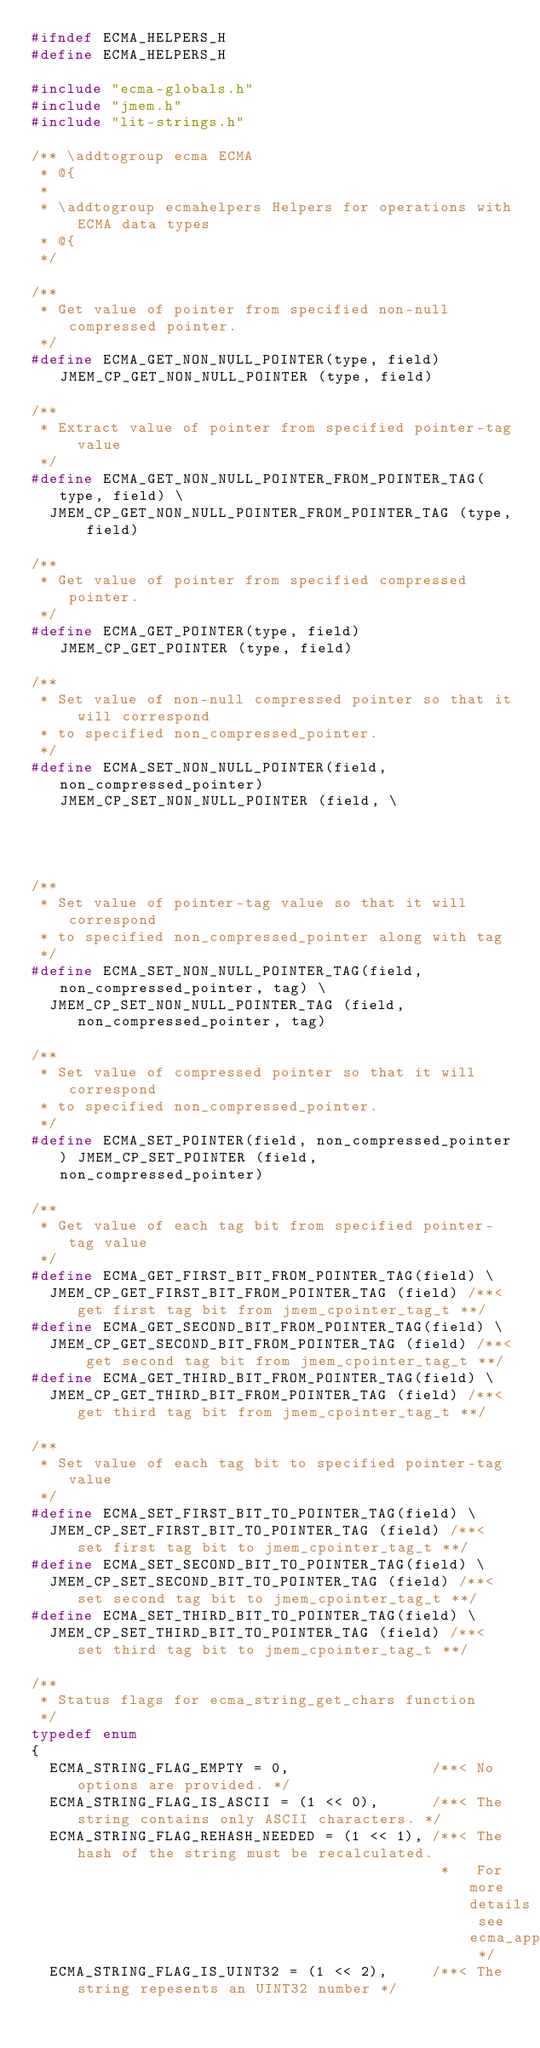Convert code to text. <code><loc_0><loc_0><loc_500><loc_500><_C_>#ifndef ECMA_HELPERS_H
#define ECMA_HELPERS_H

#include "ecma-globals.h"
#include "jmem.h"
#include "lit-strings.h"

/** \addtogroup ecma ECMA
 * @{
 *
 * \addtogroup ecmahelpers Helpers for operations with ECMA data types
 * @{
 */

/**
 * Get value of pointer from specified non-null compressed pointer.
 */
#define ECMA_GET_NON_NULL_POINTER(type, field) JMEM_CP_GET_NON_NULL_POINTER (type, field)

/**
 * Extract value of pointer from specified pointer-tag value
 */
#define ECMA_GET_NON_NULL_POINTER_FROM_POINTER_TAG(type, field) \
  JMEM_CP_GET_NON_NULL_POINTER_FROM_POINTER_TAG (type, field)

/**
 * Get value of pointer from specified compressed pointer.
 */
#define ECMA_GET_POINTER(type, field) JMEM_CP_GET_POINTER (type, field)

/**
 * Set value of non-null compressed pointer so that it will correspond
 * to specified non_compressed_pointer.
 */
#define ECMA_SET_NON_NULL_POINTER(field, non_compressed_pointer) JMEM_CP_SET_NON_NULL_POINTER (field, \
                                                                                               non_compressed_pointer)

/**
 * Set value of pointer-tag value so that it will correspond
 * to specified non_compressed_pointer along with tag
 */
#define ECMA_SET_NON_NULL_POINTER_TAG(field, non_compressed_pointer, tag) \
  JMEM_CP_SET_NON_NULL_POINTER_TAG (field, non_compressed_pointer, tag)

/**
 * Set value of compressed pointer so that it will correspond
 * to specified non_compressed_pointer.
 */
#define ECMA_SET_POINTER(field, non_compressed_pointer) JMEM_CP_SET_POINTER (field, non_compressed_pointer)

/**
 * Get value of each tag bit from specified pointer-tag value
 */
#define ECMA_GET_FIRST_BIT_FROM_POINTER_TAG(field) \
  JMEM_CP_GET_FIRST_BIT_FROM_POINTER_TAG (field) /**< get first tag bit from jmem_cpointer_tag_t **/
#define ECMA_GET_SECOND_BIT_FROM_POINTER_TAG(field) \
  JMEM_CP_GET_SECOND_BIT_FROM_POINTER_TAG (field) /**< get second tag bit from jmem_cpointer_tag_t **/
#define ECMA_GET_THIRD_BIT_FROM_POINTER_TAG(field) \
  JMEM_CP_GET_THIRD_BIT_FROM_POINTER_TAG (field) /**< get third tag bit from jmem_cpointer_tag_t **/

/**
 * Set value of each tag bit to specified pointer-tag value
 */
#define ECMA_SET_FIRST_BIT_TO_POINTER_TAG(field) \
  JMEM_CP_SET_FIRST_BIT_TO_POINTER_TAG (field) /**< set first tag bit to jmem_cpointer_tag_t **/
#define ECMA_SET_SECOND_BIT_TO_POINTER_TAG(field) \
  JMEM_CP_SET_SECOND_BIT_TO_POINTER_TAG (field) /**< set second tag bit to jmem_cpointer_tag_t **/
#define ECMA_SET_THIRD_BIT_TO_POINTER_TAG(field) \
  JMEM_CP_SET_THIRD_BIT_TO_POINTER_TAG (field) /**< set third tag bit to jmem_cpointer_tag_t **/

/**
 * Status flags for ecma_string_get_chars function
 */
typedef enum
{
  ECMA_STRING_FLAG_EMPTY = 0,                /**< No options are provided. */
  ECMA_STRING_FLAG_IS_ASCII = (1 << 0),      /**< The string contains only ASCII characters. */
  ECMA_STRING_FLAG_REHASH_NEEDED = (1 << 1), /**< The hash of the string must be recalculated.
                                              *   For more details see ecma_append_chars_to_string */
  ECMA_STRING_FLAG_IS_UINT32 = (1 << 2),     /**< The string repesents an UINT32 number */</code> 